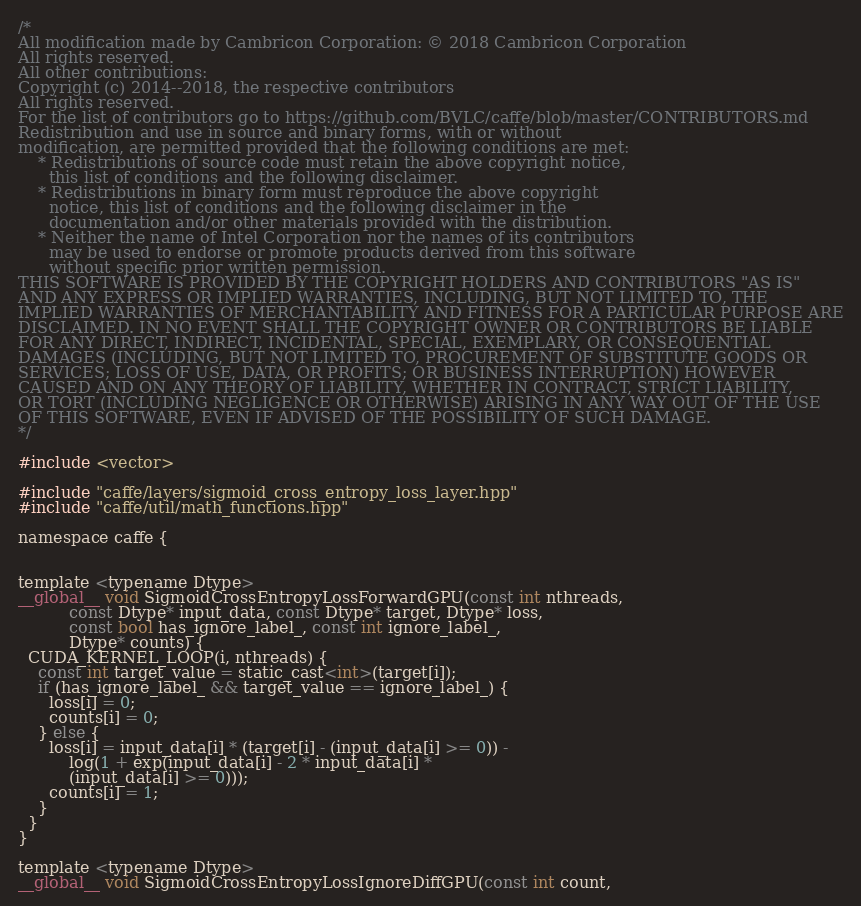Convert code to text. <code><loc_0><loc_0><loc_500><loc_500><_Cuda_>/*
All modification made by Cambricon Corporation: © 2018 Cambricon Corporation
All rights reserved.
All other contributions:
Copyright (c) 2014--2018, the respective contributors
All rights reserved.
For the list of contributors go to https://github.com/BVLC/caffe/blob/master/CONTRIBUTORS.md
Redistribution and use in source and binary forms, with or without
modification, are permitted provided that the following conditions are met:
    * Redistributions of source code must retain the above copyright notice,
      this list of conditions and the following disclaimer.
    * Redistributions in binary form must reproduce the above copyright
      notice, this list of conditions and the following disclaimer in the
      documentation and/or other materials provided with the distribution.
    * Neither the name of Intel Corporation nor the names of its contributors
      may be used to endorse or promote products derived from this software
      without specific prior written permission.
THIS SOFTWARE IS PROVIDED BY THE COPYRIGHT HOLDERS AND CONTRIBUTORS "AS IS"
AND ANY EXPRESS OR IMPLIED WARRANTIES, INCLUDING, BUT NOT LIMITED TO, THE
IMPLIED WARRANTIES OF MERCHANTABILITY AND FITNESS FOR A PARTICULAR PURPOSE ARE
DISCLAIMED. IN NO EVENT SHALL THE COPYRIGHT OWNER OR CONTRIBUTORS BE LIABLE
FOR ANY DIRECT, INDIRECT, INCIDENTAL, SPECIAL, EXEMPLARY, OR CONSEQUENTIAL
DAMAGES (INCLUDING, BUT NOT LIMITED TO, PROCUREMENT OF SUBSTITUTE GOODS OR
SERVICES; LOSS OF USE, DATA, OR PROFITS; OR BUSINESS INTERRUPTION) HOWEVER
CAUSED AND ON ANY THEORY OF LIABILITY, WHETHER IN CONTRACT, STRICT LIABILITY,
OR TORT (INCLUDING NEGLIGENCE OR OTHERWISE) ARISING IN ANY WAY OUT OF THE USE
OF THIS SOFTWARE, EVEN IF ADVISED OF THE POSSIBILITY OF SUCH DAMAGE.
*/

#include <vector>

#include "caffe/layers/sigmoid_cross_entropy_loss_layer.hpp"
#include "caffe/util/math_functions.hpp"

namespace caffe {


template <typename Dtype>
__global__ void SigmoidCrossEntropyLossForwardGPU(const int nthreads,
          const Dtype* input_data, const Dtype* target, Dtype* loss,
          const bool has_ignore_label_, const int ignore_label_,
          Dtype* counts) {
  CUDA_KERNEL_LOOP(i, nthreads) {
    const int target_value = static_cast<int>(target[i]);
    if (has_ignore_label_ && target_value == ignore_label_) {
      loss[i] = 0;
      counts[i] = 0;
    } else {
      loss[i] = input_data[i] * (target[i] - (input_data[i] >= 0)) -
          log(1 + exp(input_data[i] - 2 * input_data[i] *
          (input_data[i] >= 0)));
      counts[i] = 1;
    }
  }
}

template <typename Dtype>
__global__ void SigmoidCrossEntropyLossIgnoreDiffGPU(const int count,</code> 